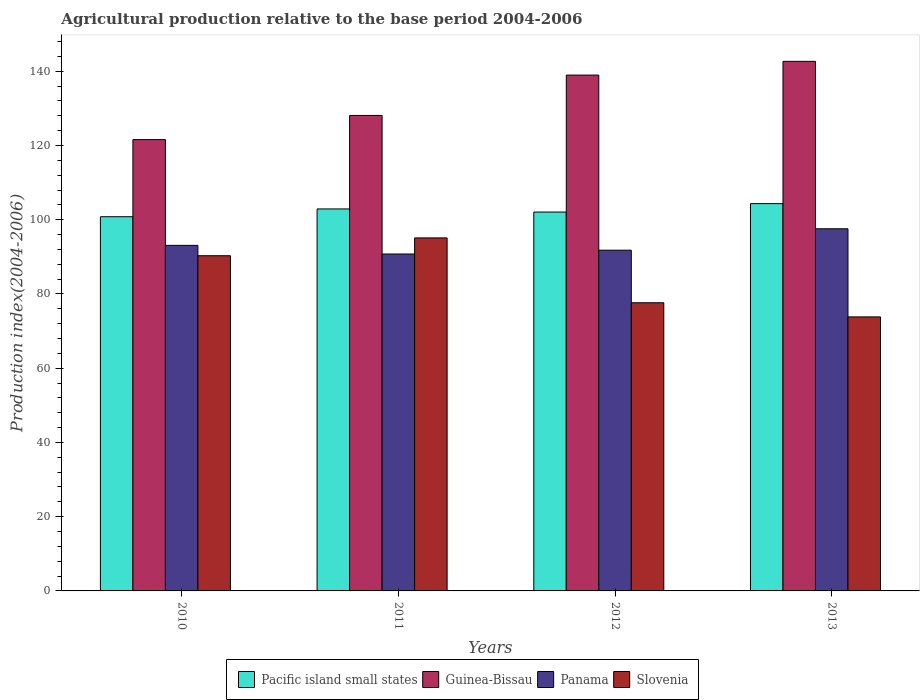How many groups of bars are there?
Your answer should be compact. 4. Are the number of bars per tick equal to the number of legend labels?
Keep it short and to the point. Yes. Are the number of bars on each tick of the X-axis equal?
Your answer should be compact. Yes. What is the label of the 3rd group of bars from the left?
Your answer should be compact. 2012. What is the agricultural production index in Panama in 2010?
Your response must be concise. 93.09. Across all years, what is the maximum agricultural production index in Guinea-Bissau?
Make the answer very short. 142.66. Across all years, what is the minimum agricultural production index in Pacific island small states?
Provide a short and direct response. 100.81. What is the total agricultural production index in Slovenia in the graph?
Offer a terse response. 336.85. What is the difference between the agricultural production index in Guinea-Bissau in 2010 and that in 2013?
Offer a very short reply. -21.08. What is the difference between the agricultural production index in Panama in 2010 and the agricultural production index in Pacific island small states in 2012?
Make the answer very short. -8.97. What is the average agricultural production index in Panama per year?
Offer a terse response. 93.3. In the year 2013, what is the difference between the agricultural production index in Slovenia and agricultural production index in Panama?
Provide a succinct answer. -23.74. What is the ratio of the agricultural production index in Pacific island small states in 2012 to that in 2013?
Offer a terse response. 0.98. Is the agricultural production index in Slovenia in 2011 less than that in 2013?
Keep it short and to the point. No. What is the difference between the highest and the second highest agricultural production index in Panama?
Your response must be concise. 4.47. What is the difference between the highest and the lowest agricultural production index in Guinea-Bissau?
Keep it short and to the point. 21.08. In how many years, is the agricultural production index in Panama greater than the average agricultural production index in Panama taken over all years?
Provide a short and direct response. 1. What does the 4th bar from the left in 2011 represents?
Provide a short and direct response. Slovenia. What does the 4th bar from the right in 2012 represents?
Ensure brevity in your answer.  Pacific island small states. Is it the case that in every year, the sum of the agricultural production index in Pacific island small states and agricultural production index in Guinea-Bissau is greater than the agricultural production index in Panama?
Your answer should be compact. Yes. How many bars are there?
Your response must be concise. 16. Are all the bars in the graph horizontal?
Offer a terse response. No. What is the difference between two consecutive major ticks on the Y-axis?
Keep it short and to the point. 20. Are the values on the major ticks of Y-axis written in scientific E-notation?
Provide a succinct answer. No. Does the graph contain grids?
Offer a terse response. No. How are the legend labels stacked?
Make the answer very short. Horizontal. What is the title of the graph?
Offer a terse response. Agricultural production relative to the base period 2004-2006. Does "Peru" appear as one of the legend labels in the graph?
Your response must be concise. No. What is the label or title of the Y-axis?
Offer a very short reply. Production index(2004-2006). What is the Production index(2004-2006) of Pacific island small states in 2010?
Provide a succinct answer. 100.81. What is the Production index(2004-2006) of Guinea-Bissau in 2010?
Offer a terse response. 121.58. What is the Production index(2004-2006) in Panama in 2010?
Your answer should be very brief. 93.09. What is the Production index(2004-2006) of Slovenia in 2010?
Keep it short and to the point. 90.3. What is the Production index(2004-2006) in Pacific island small states in 2011?
Provide a short and direct response. 102.9. What is the Production index(2004-2006) of Guinea-Bissau in 2011?
Offer a terse response. 128.09. What is the Production index(2004-2006) in Panama in 2011?
Your answer should be very brief. 90.76. What is the Production index(2004-2006) of Slovenia in 2011?
Provide a succinct answer. 95.1. What is the Production index(2004-2006) of Pacific island small states in 2012?
Offer a terse response. 102.06. What is the Production index(2004-2006) of Guinea-Bissau in 2012?
Offer a terse response. 138.96. What is the Production index(2004-2006) of Panama in 2012?
Your response must be concise. 91.79. What is the Production index(2004-2006) of Slovenia in 2012?
Give a very brief answer. 77.63. What is the Production index(2004-2006) in Pacific island small states in 2013?
Offer a terse response. 104.33. What is the Production index(2004-2006) in Guinea-Bissau in 2013?
Provide a short and direct response. 142.66. What is the Production index(2004-2006) in Panama in 2013?
Provide a short and direct response. 97.56. What is the Production index(2004-2006) in Slovenia in 2013?
Keep it short and to the point. 73.82. Across all years, what is the maximum Production index(2004-2006) of Pacific island small states?
Your answer should be very brief. 104.33. Across all years, what is the maximum Production index(2004-2006) in Guinea-Bissau?
Ensure brevity in your answer.  142.66. Across all years, what is the maximum Production index(2004-2006) in Panama?
Offer a terse response. 97.56. Across all years, what is the maximum Production index(2004-2006) in Slovenia?
Your answer should be compact. 95.1. Across all years, what is the minimum Production index(2004-2006) in Pacific island small states?
Provide a short and direct response. 100.81. Across all years, what is the minimum Production index(2004-2006) of Guinea-Bissau?
Give a very brief answer. 121.58. Across all years, what is the minimum Production index(2004-2006) in Panama?
Your response must be concise. 90.76. Across all years, what is the minimum Production index(2004-2006) in Slovenia?
Provide a succinct answer. 73.82. What is the total Production index(2004-2006) of Pacific island small states in the graph?
Offer a very short reply. 410.11. What is the total Production index(2004-2006) in Guinea-Bissau in the graph?
Ensure brevity in your answer.  531.29. What is the total Production index(2004-2006) of Panama in the graph?
Make the answer very short. 373.2. What is the total Production index(2004-2006) in Slovenia in the graph?
Provide a succinct answer. 336.85. What is the difference between the Production index(2004-2006) of Pacific island small states in 2010 and that in 2011?
Your answer should be very brief. -2.1. What is the difference between the Production index(2004-2006) of Guinea-Bissau in 2010 and that in 2011?
Your answer should be very brief. -6.51. What is the difference between the Production index(2004-2006) in Panama in 2010 and that in 2011?
Your answer should be compact. 2.33. What is the difference between the Production index(2004-2006) in Slovenia in 2010 and that in 2011?
Make the answer very short. -4.8. What is the difference between the Production index(2004-2006) of Pacific island small states in 2010 and that in 2012?
Your response must be concise. -1.26. What is the difference between the Production index(2004-2006) in Guinea-Bissau in 2010 and that in 2012?
Offer a terse response. -17.38. What is the difference between the Production index(2004-2006) of Slovenia in 2010 and that in 2012?
Your answer should be compact. 12.67. What is the difference between the Production index(2004-2006) in Pacific island small states in 2010 and that in 2013?
Provide a succinct answer. -3.53. What is the difference between the Production index(2004-2006) of Guinea-Bissau in 2010 and that in 2013?
Offer a terse response. -21.08. What is the difference between the Production index(2004-2006) of Panama in 2010 and that in 2013?
Provide a succinct answer. -4.47. What is the difference between the Production index(2004-2006) of Slovenia in 2010 and that in 2013?
Give a very brief answer. 16.48. What is the difference between the Production index(2004-2006) in Pacific island small states in 2011 and that in 2012?
Make the answer very short. 0.84. What is the difference between the Production index(2004-2006) of Guinea-Bissau in 2011 and that in 2012?
Make the answer very short. -10.87. What is the difference between the Production index(2004-2006) in Panama in 2011 and that in 2012?
Make the answer very short. -1.03. What is the difference between the Production index(2004-2006) in Slovenia in 2011 and that in 2012?
Make the answer very short. 17.47. What is the difference between the Production index(2004-2006) of Pacific island small states in 2011 and that in 2013?
Your answer should be compact. -1.43. What is the difference between the Production index(2004-2006) of Guinea-Bissau in 2011 and that in 2013?
Provide a short and direct response. -14.57. What is the difference between the Production index(2004-2006) of Panama in 2011 and that in 2013?
Your response must be concise. -6.8. What is the difference between the Production index(2004-2006) in Slovenia in 2011 and that in 2013?
Keep it short and to the point. 21.28. What is the difference between the Production index(2004-2006) of Pacific island small states in 2012 and that in 2013?
Offer a terse response. -2.27. What is the difference between the Production index(2004-2006) in Panama in 2012 and that in 2013?
Make the answer very short. -5.77. What is the difference between the Production index(2004-2006) in Slovenia in 2012 and that in 2013?
Ensure brevity in your answer.  3.81. What is the difference between the Production index(2004-2006) in Pacific island small states in 2010 and the Production index(2004-2006) in Guinea-Bissau in 2011?
Your answer should be compact. -27.28. What is the difference between the Production index(2004-2006) in Pacific island small states in 2010 and the Production index(2004-2006) in Panama in 2011?
Provide a succinct answer. 10.05. What is the difference between the Production index(2004-2006) of Pacific island small states in 2010 and the Production index(2004-2006) of Slovenia in 2011?
Offer a terse response. 5.71. What is the difference between the Production index(2004-2006) of Guinea-Bissau in 2010 and the Production index(2004-2006) of Panama in 2011?
Ensure brevity in your answer.  30.82. What is the difference between the Production index(2004-2006) in Guinea-Bissau in 2010 and the Production index(2004-2006) in Slovenia in 2011?
Your response must be concise. 26.48. What is the difference between the Production index(2004-2006) of Panama in 2010 and the Production index(2004-2006) of Slovenia in 2011?
Your response must be concise. -2.01. What is the difference between the Production index(2004-2006) in Pacific island small states in 2010 and the Production index(2004-2006) in Guinea-Bissau in 2012?
Offer a terse response. -38.15. What is the difference between the Production index(2004-2006) of Pacific island small states in 2010 and the Production index(2004-2006) of Panama in 2012?
Your answer should be very brief. 9.02. What is the difference between the Production index(2004-2006) in Pacific island small states in 2010 and the Production index(2004-2006) in Slovenia in 2012?
Offer a terse response. 23.18. What is the difference between the Production index(2004-2006) in Guinea-Bissau in 2010 and the Production index(2004-2006) in Panama in 2012?
Your answer should be very brief. 29.79. What is the difference between the Production index(2004-2006) in Guinea-Bissau in 2010 and the Production index(2004-2006) in Slovenia in 2012?
Make the answer very short. 43.95. What is the difference between the Production index(2004-2006) of Panama in 2010 and the Production index(2004-2006) of Slovenia in 2012?
Keep it short and to the point. 15.46. What is the difference between the Production index(2004-2006) of Pacific island small states in 2010 and the Production index(2004-2006) of Guinea-Bissau in 2013?
Your answer should be very brief. -41.85. What is the difference between the Production index(2004-2006) of Pacific island small states in 2010 and the Production index(2004-2006) of Panama in 2013?
Provide a succinct answer. 3.25. What is the difference between the Production index(2004-2006) of Pacific island small states in 2010 and the Production index(2004-2006) of Slovenia in 2013?
Provide a succinct answer. 26.99. What is the difference between the Production index(2004-2006) in Guinea-Bissau in 2010 and the Production index(2004-2006) in Panama in 2013?
Ensure brevity in your answer.  24.02. What is the difference between the Production index(2004-2006) of Guinea-Bissau in 2010 and the Production index(2004-2006) of Slovenia in 2013?
Keep it short and to the point. 47.76. What is the difference between the Production index(2004-2006) in Panama in 2010 and the Production index(2004-2006) in Slovenia in 2013?
Provide a short and direct response. 19.27. What is the difference between the Production index(2004-2006) of Pacific island small states in 2011 and the Production index(2004-2006) of Guinea-Bissau in 2012?
Your answer should be very brief. -36.06. What is the difference between the Production index(2004-2006) of Pacific island small states in 2011 and the Production index(2004-2006) of Panama in 2012?
Keep it short and to the point. 11.11. What is the difference between the Production index(2004-2006) of Pacific island small states in 2011 and the Production index(2004-2006) of Slovenia in 2012?
Your response must be concise. 25.27. What is the difference between the Production index(2004-2006) of Guinea-Bissau in 2011 and the Production index(2004-2006) of Panama in 2012?
Keep it short and to the point. 36.3. What is the difference between the Production index(2004-2006) of Guinea-Bissau in 2011 and the Production index(2004-2006) of Slovenia in 2012?
Make the answer very short. 50.46. What is the difference between the Production index(2004-2006) of Panama in 2011 and the Production index(2004-2006) of Slovenia in 2012?
Provide a short and direct response. 13.13. What is the difference between the Production index(2004-2006) of Pacific island small states in 2011 and the Production index(2004-2006) of Guinea-Bissau in 2013?
Provide a short and direct response. -39.76. What is the difference between the Production index(2004-2006) in Pacific island small states in 2011 and the Production index(2004-2006) in Panama in 2013?
Ensure brevity in your answer.  5.34. What is the difference between the Production index(2004-2006) in Pacific island small states in 2011 and the Production index(2004-2006) in Slovenia in 2013?
Your answer should be compact. 29.08. What is the difference between the Production index(2004-2006) of Guinea-Bissau in 2011 and the Production index(2004-2006) of Panama in 2013?
Offer a terse response. 30.53. What is the difference between the Production index(2004-2006) of Guinea-Bissau in 2011 and the Production index(2004-2006) of Slovenia in 2013?
Give a very brief answer. 54.27. What is the difference between the Production index(2004-2006) in Panama in 2011 and the Production index(2004-2006) in Slovenia in 2013?
Provide a short and direct response. 16.94. What is the difference between the Production index(2004-2006) in Pacific island small states in 2012 and the Production index(2004-2006) in Guinea-Bissau in 2013?
Offer a very short reply. -40.6. What is the difference between the Production index(2004-2006) of Pacific island small states in 2012 and the Production index(2004-2006) of Panama in 2013?
Your answer should be compact. 4.5. What is the difference between the Production index(2004-2006) in Pacific island small states in 2012 and the Production index(2004-2006) in Slovenia in 2013?
Your response must be concise. 28.24. What is the difference between the Production index(2004-2006) in Guinea-Bissau in 2012 and the Production index(2004-2006) in Panama in 2013?
Provide a short and direct response. 41.4. What is the difference between the Production index(2004-2006) of Guinea-Bissau in 2012 and the Production index(2004-2006) of Slovenia in 2013?
Your answer should be compact. 65.14. What is the difference between the Production index(2004-2006) of Panama in 2012 and the Production index(2004-2006) of Slovenia in 2013?
Give a very brief answer. 17.97. What is the average Production index(2004-2006) of Pacific island small states per year?
Offer a terse response. 102.53. What is the average Production index(2004-2006) of Guinea-Bissau per year?
Make the answer very short. 132.82. What is the average Production index(2004-2006) in Panama per year?
Give a very brief answer. 93.3. What is the average Production index(2004-2006) in Slovenia per year?
Keep it short and to the point. 84.21. In the year 2010, what is the difference between the Production index(2004-2006) in Pacific island small states and Production index(2004-2006) in Guinea-Bissau?
Offer a very short reply. -20.77. In the year 2010, what is the difference between the Production index(2004-2006) of Pacific island small states and Production index(2004-2006) of Panama?
Provide a short and direct response. 7.72. In the year 2010, what is the difference between the Production index(2004-2006) of Pacific island small states and Production index(2004-2006) of Slovenia?
Provide a short and direct response. 10.51. In the year 2010, what is the difference between the Production index(2004-2006) of Guinea-Bissau and Production index(2004-2006) of Panama?
Provide a short and direct response. 28.49. In the year 2010, what is the difference between the Production index(2004-2006) of Guinea-Bissau and Production index(2004-2006) of Slovenia?
Ensure brevity in your answer.  31.28. In the year 2010, what is the difference between the Production index(2004-2006) in Panama and Production index(2004-2006) in Slovenia?
Your answer should be very brief. 2.79. In the year 2011, what is the difference between the Production index(2004-2006) of Pacific island small states and Production index(2004-2006) of Guinea-Bissau?
Offer a terse response. -25.19. In the year 2011, what is the difference between the Production index(2004-2006) of Pacific island small states and Production index(2004-2006) of Panama?
Provide a succinct answer. 12.14. In the year 2011, what is the difference between the Production index(2004-2006) of Pacific island small states and Production index(2004-2006) of Slovenia?
Your response must be concise. 7.8. In the year 2011, what is the difference between the Production index(2004-2006) of Guinea-Bissau and Production index(2004-2006) of Panama?
Ensure brevity in your answer.  37.33. In the year 2011, what is the difference between the Production index(2004-2006) of Guinea-Bissau and Production index(2004-2006) of Slovenia?
Your answer should be compact. 32.99. In the year 2011, what is the difference between the Production index(2004-2006) in Panama and Production index(2004-2006) in Slovenia?
Give a very brief answer. -4.34. In the year 2012, what is the difference between the Production index(2004-2006) in Pacific island small states and Production index(2004-2006) in Guinea-Bissau?
Your response must be concise. -36.9. In the year 2012, what is the difference between the Production index(2004-2006) in Pacific island small states and Production index(2004-2006) in Panama?
Your answer should be compact. 10.27. In the year 2012, what is the difference between the Production index(2004-2006) in Pacific island small states and Production index(2004-2006) in Slovenia?
Keep it short and to the point. 24.43. In the year 2012, what is the difference between the Production index(2004-2006) of Guinea-Bissau and Production index(2004-2006) of Panama?
Offer a very short reply. 47.17. In the year 2012, what is the difference between the Production index(2004-2006) of Guinea-Bissau and Production index(2004-2006) of Slovenia?
Your response must be concise. 61.33. In the year 2012, what is the difference between the Production index(2004-2006) in Panama and Production index(2004-2006) in Slovenia?
Provide a succinct answer. 14.16. In the year 2013, what is the difference between the Production index(2004-2006) in Pacific island small states and Production index(2004-2006) in Guinea-Bissau?
Offer a very short reply. -38.33. In the year 2013, what is the difference between the Production index(2004-2006) in Pacific island small states and Production index(2004-2006) in Panama?
Provide a succinct answer. 6.77. In the year 2013, what is the difference between the Production index(2004-2006) in Pacific island small states and Production index(2004-2006) in Slovenia?
Provide a succinct answer. 30.51. In the year 2013, what is the difference between the Production index(2004-2006) of Guinea-Bissau and Production index(2004-2006) of Panama?
Your answer should be very brief. 45.1. In the year 2013, what is the difference between the Production index(2004-2006) in Guinea-Bissau and Production index(2004-2006) in Slovenia?
Offer a terse response. 68.84. In the year 2013, what is the difference between the Production index(2004-2006) of Panama and Production index(2004-2006) of Slovenia?
Make the answer very short. 23.74. What is the ratio of the Production index(2004-2006) in Pacific island small states in 2010 to that in 2011?
Make the answer very short. 0.98. What is the ratio of the Production index(2004-2006) in Guinea-Bissau in 2010 to that in 2011?
Keep it short and to the point. 0.95. What is the ratio of the Production index(2004-2006) of Panama in 2010 to that in 2011?
Your answer should be very brief. 1.03. What is the ratio of the Production index(2004-2006) in Slovenia in 2010 to that in 2011?
Your answer should be compact. 0.95. What is the ratio of the Production index(2004-2006) of Guinea-Bissau in 2010 to that in 2012?
Offer a terse response. 0.87. What is the ratio of the Production index(2004-2006) in Panama in 2010 to that in 2012?
Provide a short and direct response. 1.01. What is the ratio of the Production index(2004-2006) in Slovenia in 2010 to that in 2012?
Offer a terse response. 1.16. What is the ratio of the Production index(2004-2006) of Pacific island small states in 2010 to that in 2013?
Keep it short and to the point. 0.97. What is the ratio of the Production index(2004-2006) in Guinea-Bissau in 2010 to that in 2013?
Keep it short and to the point. 0.85. What is the ratio of the Production index(2004-2006) of Panama in 2010 to that in 2013?
Make the answer very short. 0.95. What is the ratio of the Production index(2004-2006) in Slovenia in 2010 to that in 2013?
Keep it short and to the point. 1.22. What is the ratio of the Production index(2004-2006) in Pacific island small states in 2011 to that in 2012?
Offer a very short reply. 1.01. What is the ratio of the Production index(2004-2006) of Guinea-Bissau in 2011 to that in 2012?
Your answer should be compact. 0.92. What is the ratio of the Production index(2004-2006) in Panama in 2011 to that in 2012?
Offer a terse response. 0.99. What is the ratio of the Production index(2004-2006) of Slovenia in 2011 to that in 2012?
Make the answer very short. 1.23. What is the ratio of the Production index(2004-2006) in Pacific island small states in 2011 to that in 2013?
Offer a terse response. 0.99. What is the ratio of the Production index(2004-2006) in Guinea-Bissau in 2011 to that in 2013?
Your response must be concise. 0.9. What is the ratio of the Production index(2004-2006) in Panama in 2011 to that in 2013?
Your answer should be compact. 0.93. What is the ratio of the Production index(2004-2006) of Slovenia in 2011 to that in 2013?
Provide a short and direct response. 1.29. What is the ratio of the Production index(2004-2006) in Pacific island small states in 2012 to that in 2013?
Your answer should be very brief. 0.98. What is the ratio of the Production index(2004-2006) in Guinea-Bissau in 2012 to that in 2013?
Provide a succinct answer. 0.97. What is the ratio of the Production index(2004-2006) in Panama in 2012 to that in 2013?
Make the answer very short. 0.94. What is the ratio of the Production index(2004-2006) in Slovenia in 2012 to that in 2013?
Make the answer very short. 1.05. What is the difference between the highest and the second highest Production index(2004-2006) of Pacific island small states?
Provide a short and direct response. 1.43. What is the difference between the highest and the second highest Production index(2004-2006) of Panama?
Offer a very short reply. 4.47. What is the difference between the highest and the second highest Production index(2004-2006) in Slovenia?
Give a very brief answer. 4.8. What is the difference between the highest and the lowest Production index(2004-2006) of Pacific island small states?
Your response must be concise. 3.53. What is the difference between the highest and the lowest Production index(2004-2006) of Guinea-Bissau?
Your response must be concise. 21.08. What is the difference between the highest and the lowest Production index(2004-2006) in Panama?
Make the answer very short. 6.8. What is the difference between the highest and the lowest Production index(2004-2006) in Slovenia?
Offer a very short reply. 21.28. 